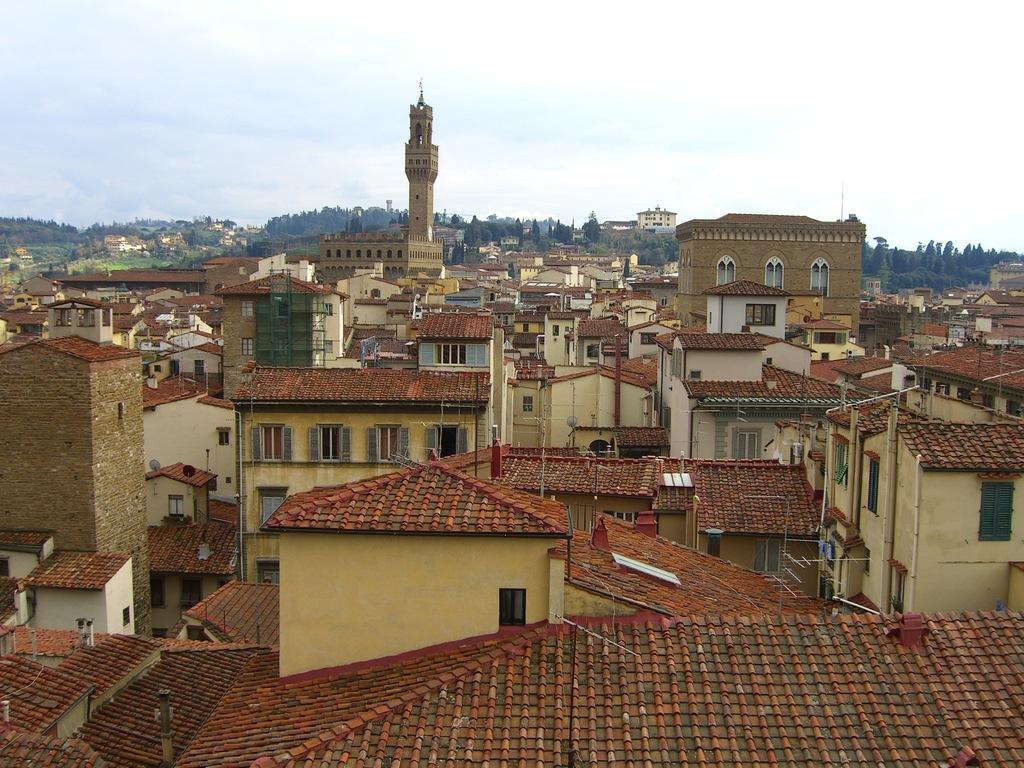What perspective is the image taken from? The image is taken from a top view. What can be seen in the image from this perspective? There are many buildings in the image. What is visible in the background of the image? There are trees and mountains in the background of the image. What is visible at the top of the image? The sky is visible at the top of the image. Can you see a giraffe standing among the buildings in the image? No, there is no giraffe present in the image. How comfortable are the chairs in the buildings shown in the image? The image does not provide information about the comfort of chairs inside the buildings. 